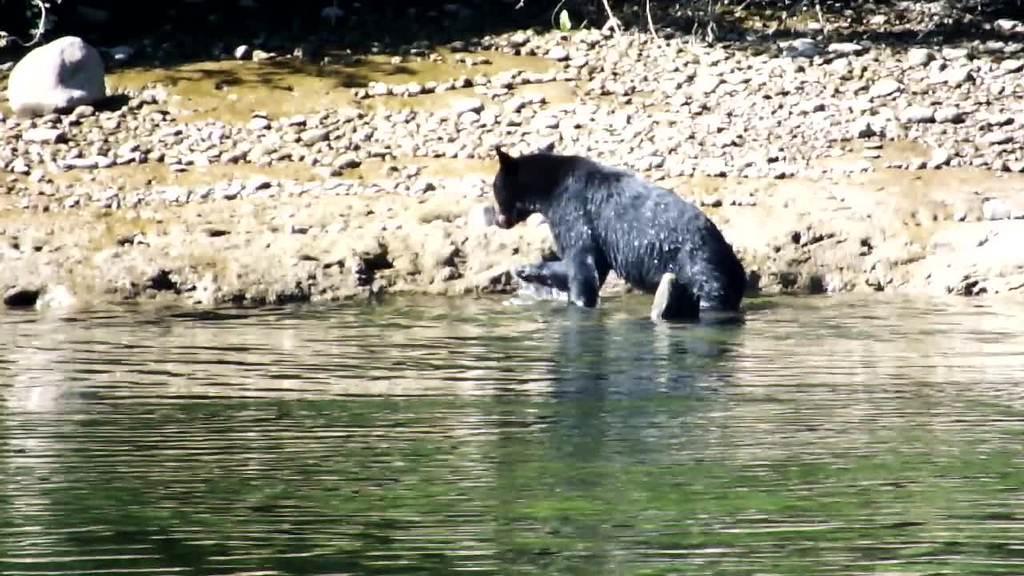In one or two sentences, can you explain what this image depicts? In this image we can see an animal on the surface of the water. In the background we can see the stones on the land. 